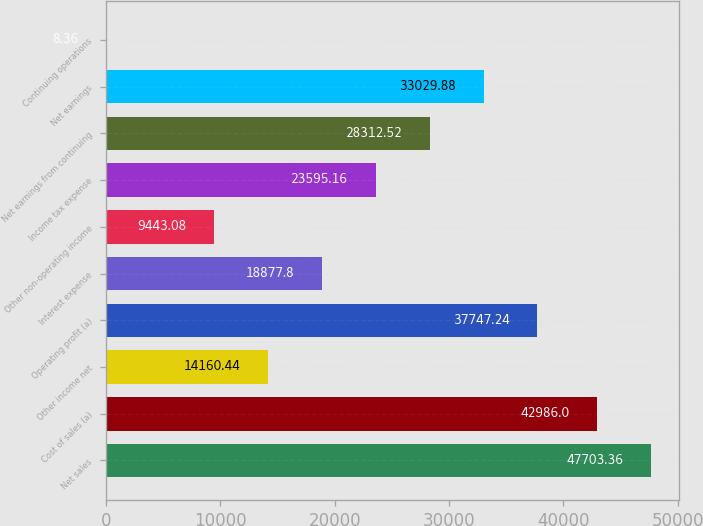<chart> <loc_0><loc_0><loc_500><loc_500><bar_chart><fcel>Net sales<fcel>Cost of sales (a)<fcel>Other income net<fcel>Operating profit (a)<fcel>Interest expense<fcel>Other non-operating income<fcel>Income tax expense<fcel>Net earnings from continuing<fcel>Net earnings<fcel>Continuing operations<nl><fcel>47703.4<fcel>42986<fcel>14160.4<fcel>37747.2<fcel>18877.8<fcel>9443.08<fcel>23595.2<fcel>28312.5<fcel>33029.9<fcel>8.36<nl></chart> 